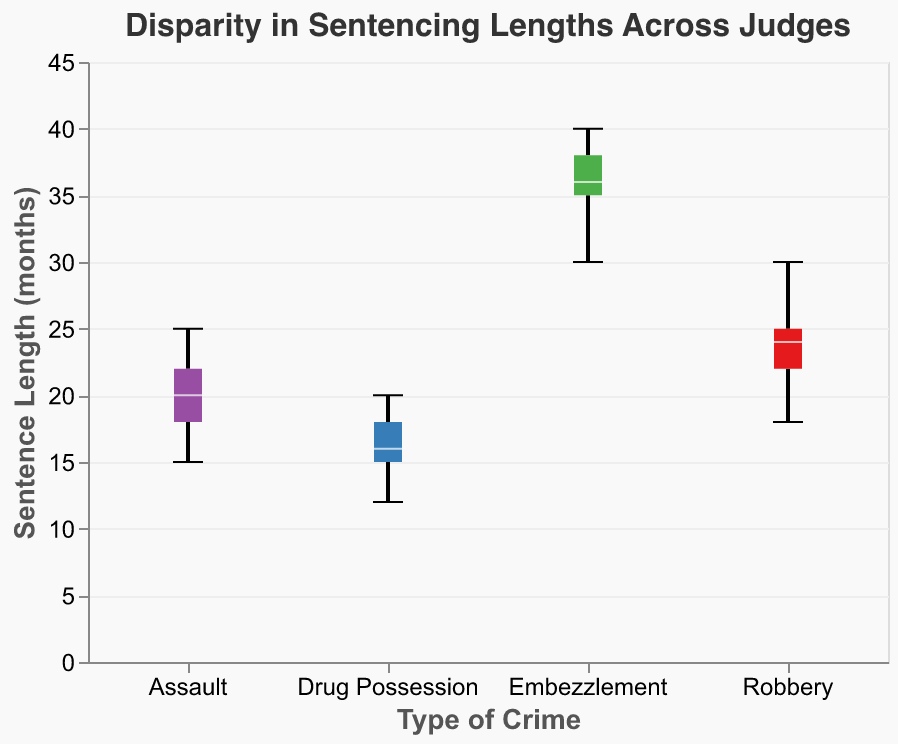What's the minimum sentence length for Drug Possession? First, locate the "Drug Possession" category on the x-axis. The minimum sentence length is at the lower end of the boxplot's whisker.
Answer: 12 months Which crime has the highest median sentence length? To find this, check the middle line within each box representing the median value. The crime with the highest median is the one with the highest middle line.
Answer: Embezzlement What is the range of sentence lengths for Robbery? Locate the "Robbery" category on the x-axis, then identify the minimum and maximum points of the whiskers. The range is the difference between these two values.
Answer: 18 to 30 months Compare the median sentence lengths of Assault and Drug Possession. Which one is higher? Locate both categories on the x-axis and compare the middle lines in each box (the median). The one with the higher median line has the higher median sentence length.
Answer: Assault What's the interquartile range (IQR) for Robbery? Identify the 25th percentile (bottom edge of the box) and the 75th percentile (top edge of the box) for Robbery. The IQR is the difference between these two values.
Answer: 22 to 24 months Which Judge appears to have the most consistent sentencing across different crimes? Consistency can be measured by the spread of the boxplots. Judge consistency can be inferred by assessing which judge has the smallest spread (IQR) in most cases.
Answer: Judge records are not shown, but generally, the smallest IQR indicates consistency Is there an outlier in the sentencing data for any crime? Outliers are points that are visibly separate from the whiskers of the boxplot. Look for any dots outside the whiskers.
Answer: No outliers What is the median sentence length for Robbery? Find the middle line within the boxplot for Robbery. This line represents the median.
Answer: 24 months 